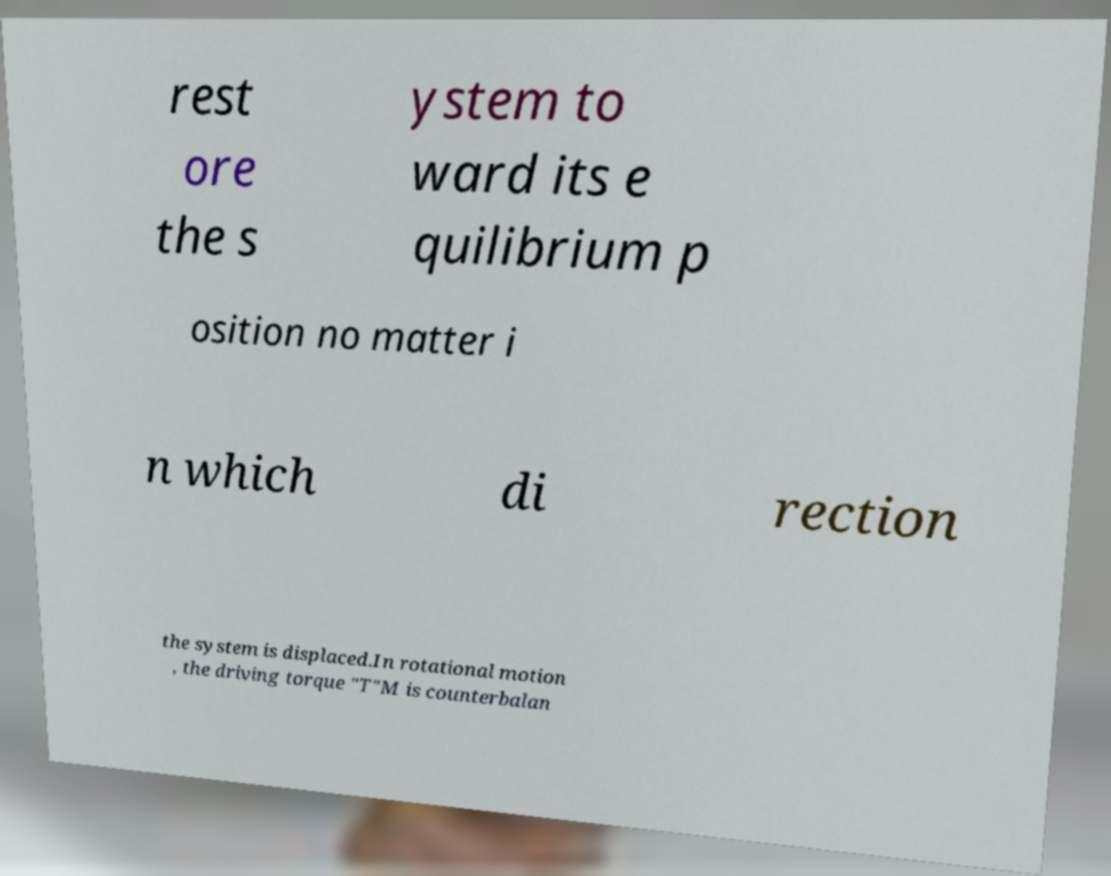I need the written content from this picture converted into text. Can you do that? rest ore the s ystem to ward its e quilibrium p osition no matter i n which di rection the system is displaced.In rotational motion , the driving torque "T"M is counterbalan 